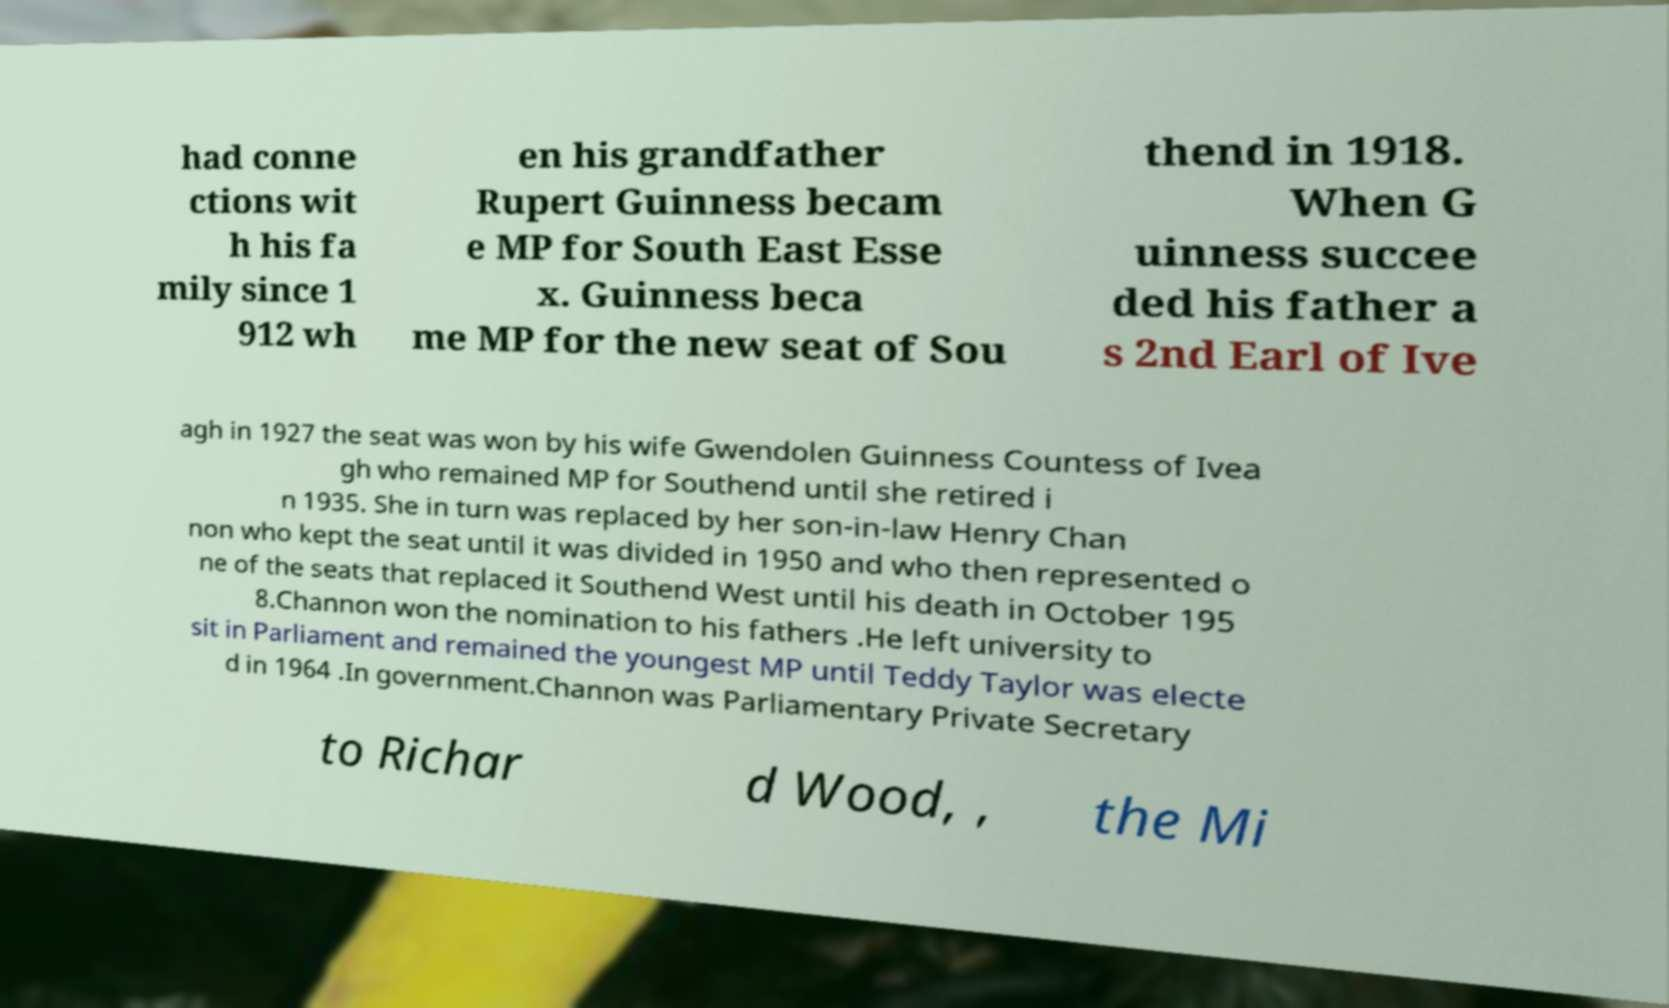Could you extract and type out the text from this image? had conne ctions wit h his fa mily since 1 912 wh en his grandfather Rupert Guinness becam e MP for South East Esse x. Guinness beca me MP for the new seat of Sou thend in 1918. When G uinness succee ded his father a s 2nd Earl of Ive agh in 1927 the seat was won by his wife Gwendolen Guinness Countess of Ivea gh who remained MP for Southend until she retired i n 1935. She in turn was replaced by her son-in-law Henry Chan non who kept the seat until it was divided in 1950 and who then represented o ne of the seats that replaced it Southend West until his death in October 195 8.Channon won the nomination to his fathers .He left university to sit in Parliament and remained the youngest MP until Teddy Taylor was electe d in 1964 .In government.Channon was Parliamentary Private Secretary to Richar d Wood, , the Mi 